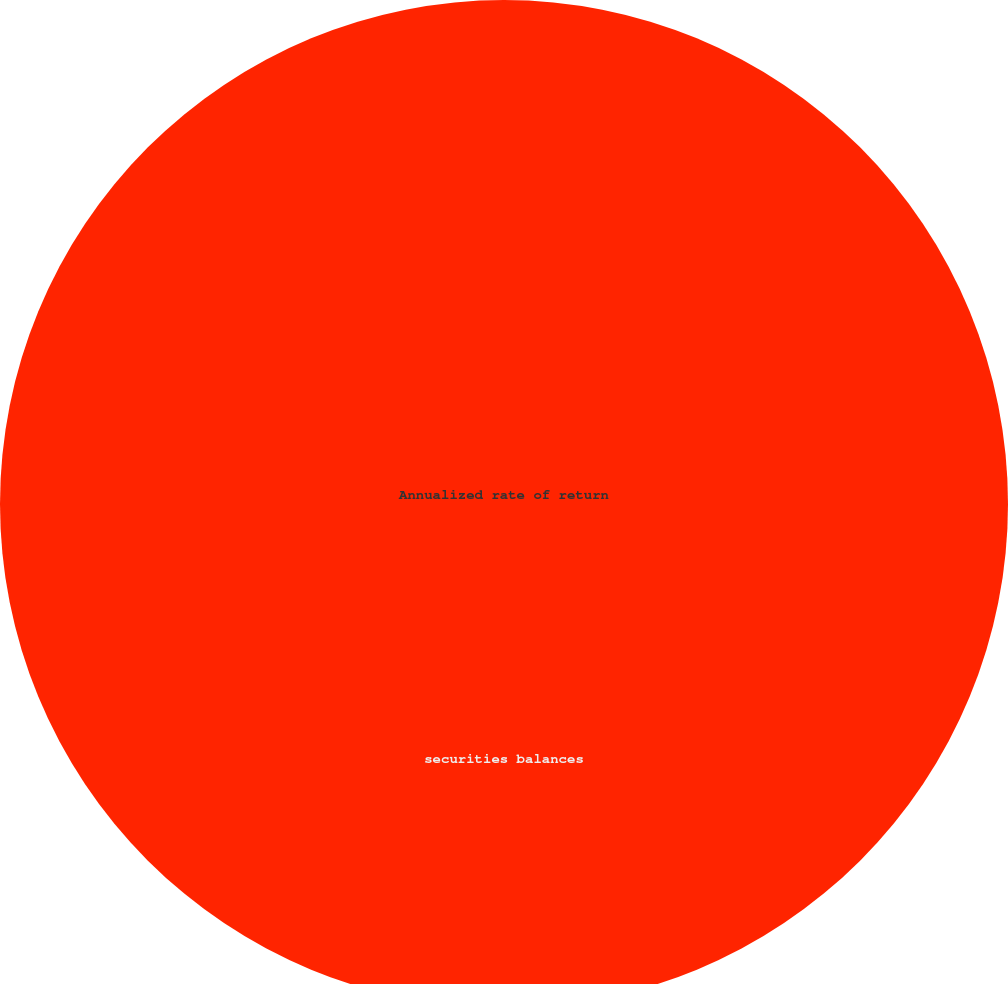Convert chart. <chart><loc_0><loc_0><loc_500><loc_500><pie_chart><fcel>securities balances<fcel>Annualized rate of return<nl><fcel>100.0%<fcel>0.0%<nl></chart> 